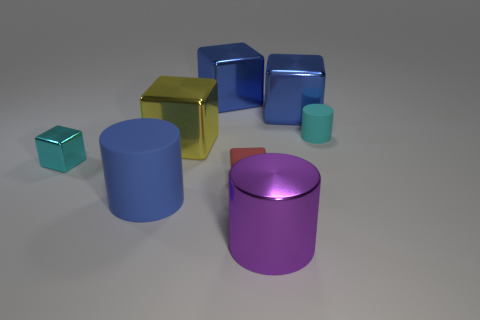There is a red rubber thing that is the same shape as the large yellow object; what is its size?
Keep it short and to the point. Small. There is a object that is the same color as the small metallic block; what material is it?
Keep it short and to the point. Rubber. There is a big blue object that is the same shape as the small cyan rubber object; what is it made of?
Your answer should be compact. Rubber. Does the red thing have the same material as the big blue cylinder?
Ensure brevity in your answer.  Yes. There is a cyan shiny object that is the same size as the cyan rubber cylinder; what shape is it?
Make the answer very short. Cube. Are there more large purple metal objects than red metallic cylinders?
Give a very brief answer. Yes. What is the large blue object that is both to the left of the red object and behind the red object made of?
Your response must be concise. Metal. How many other things are there of the same material as the tiny red thing?
Offer a very short reply. 2. What number of large metallic blocks are the same color as the big matte object?
Your answer should be compact. 2. There is a cyan object that is in front of the cylinder behind the rubber object that is left of the yellow thing; what is its size?
Your response must be concise. Small. 